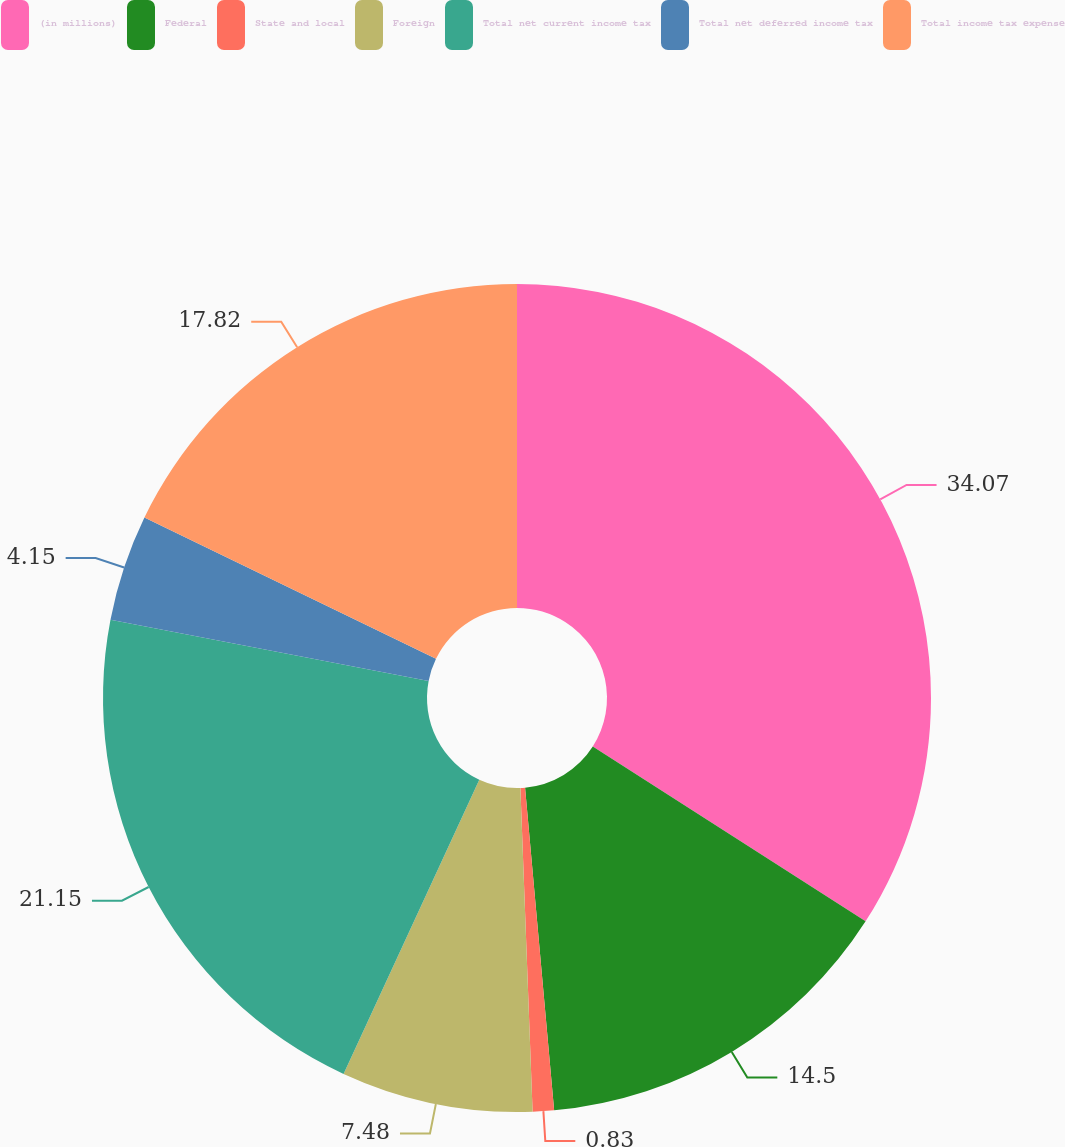Convert chart to OTSL. <chart><loc_0><loc_0><loc_500><loc_500><pie_chart><fcel>(in millions)<fcel>Federal<fcel>State and local<fcel>Foreign<fcel>Total net current income tax<fcel>Total net deferred income tax<fcel>Total income tax expense<nl><fcel>34.07%<fcel>14.5%<fcel>0.83%<fcel>7.48%<fcel>21.15%<fcel>4.15%<fcel>17.82%<nl></chart> 